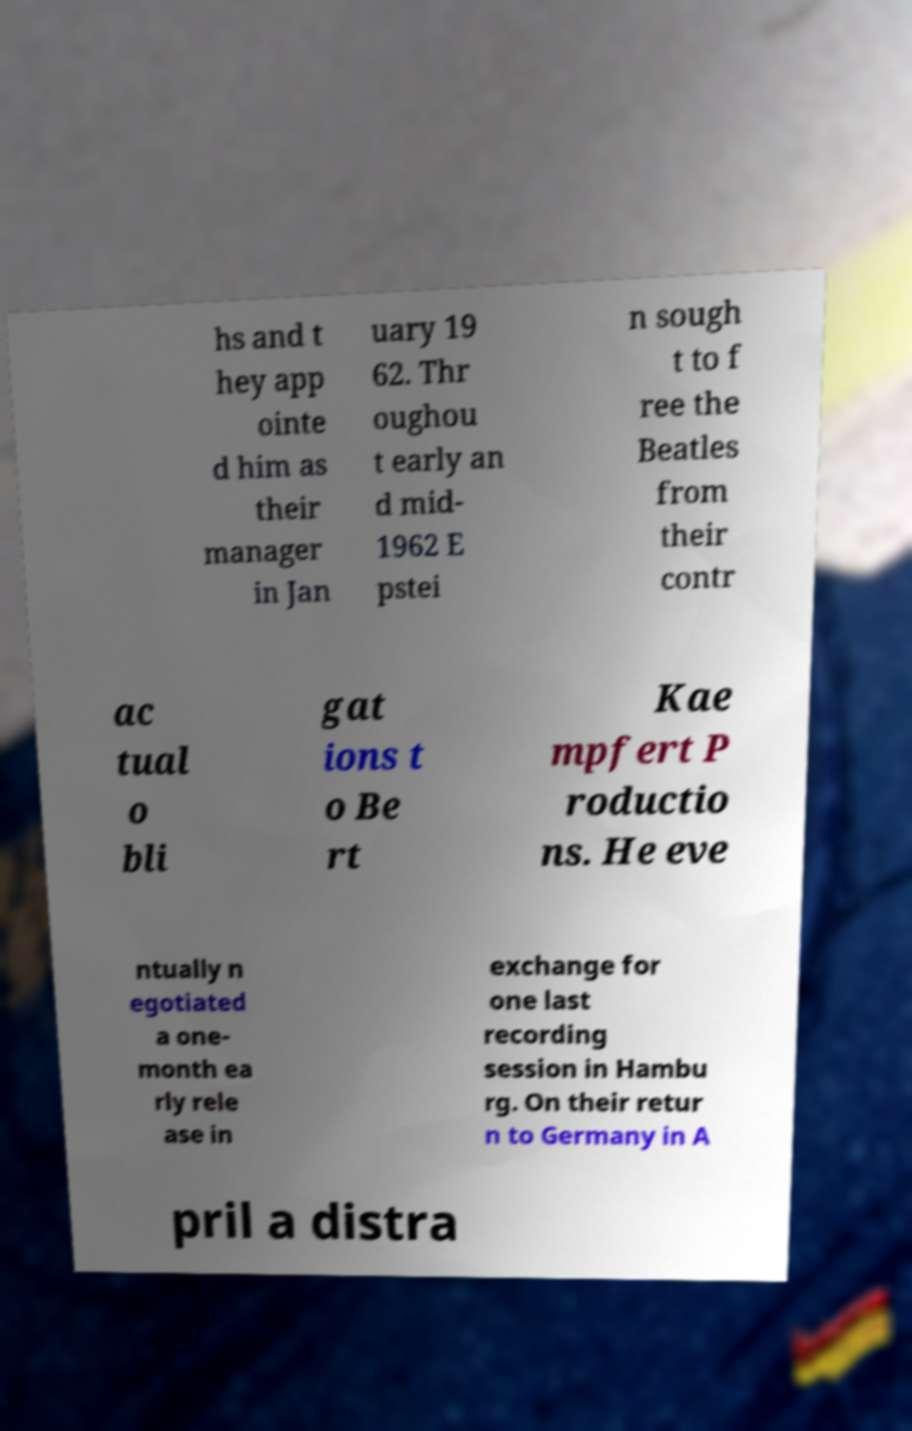Could you assist in decoding the text presented in this image and type it out clearly? hs and t hey app ointe d him as their manager in Jan uary 19 62. Thr oughou t early an d mid- 1962 E pstei n sough t to f ree the Beatles from their contr ac tual o bli gat ions t o Be rt Kae mpfert P roductio ns. He eve ntually n egotiated a one- month ea rly rele ase in exchange for one last recording session in Hambu rg. On their retur n to Germany in A pril a distra 